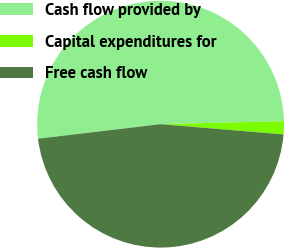Convert chart. <chart><loc_0><loc_0><loc_500><loc_500><pie_chart><fcel>Cash flow provided by<fcel>Capital expenditures for<fcel>Free cash flow<nl><fcel>51.48%<fcel>1.72%<fcel>46.8%<nl></chart> 